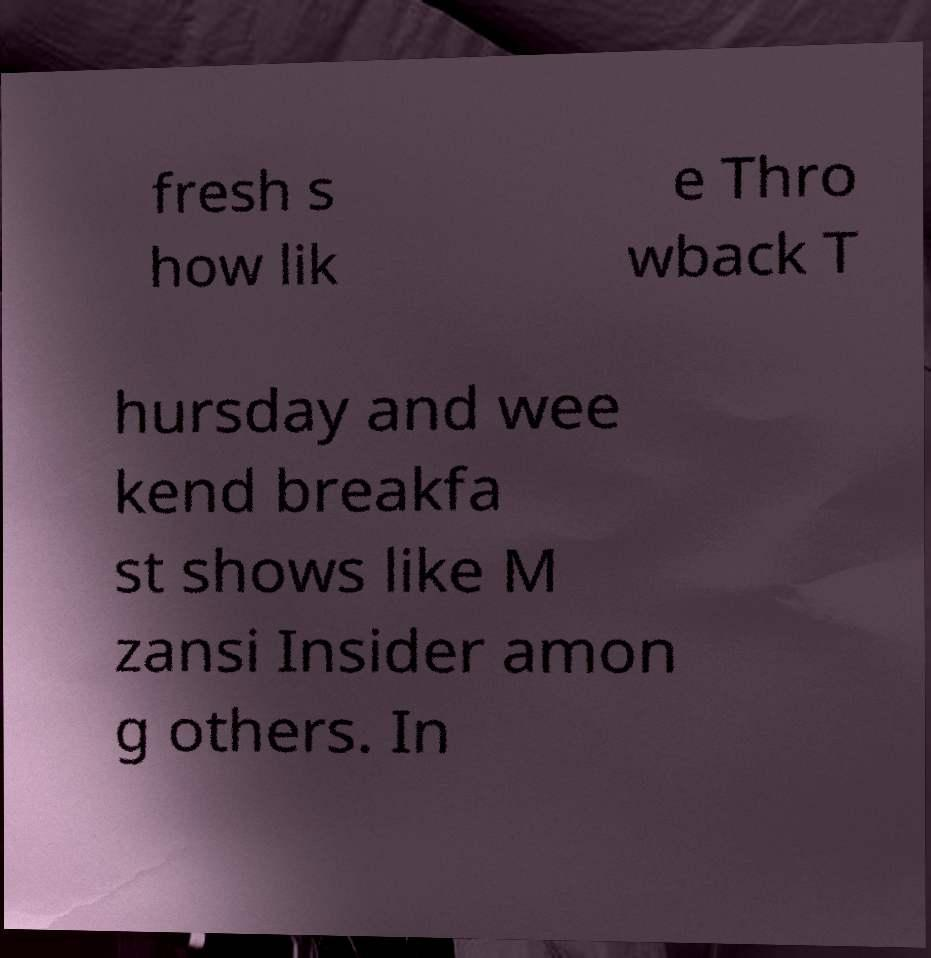What messages or text are displayed in this image? I need them in a readable, typed format. fresh s how lik e Thro wback T hursday and wee kend breakfa st shows like M zansi Insider amon g others. In 